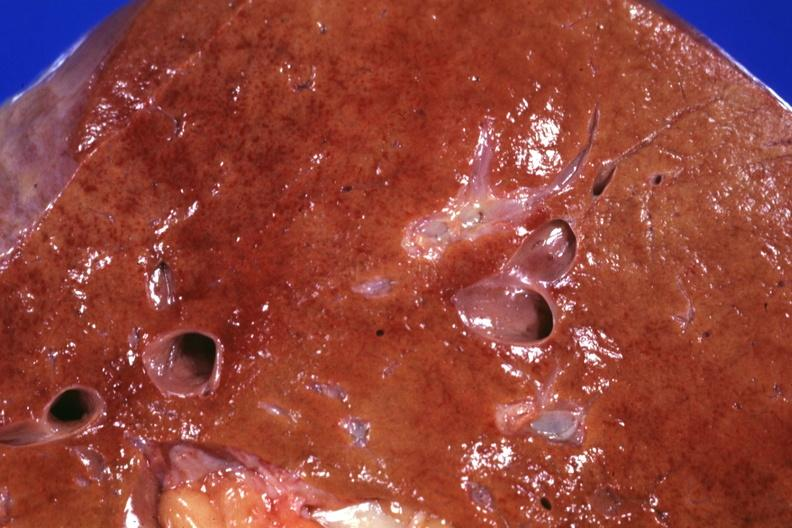s hepatobiliary present?
Answer the question using a single word or phrase. Yes 